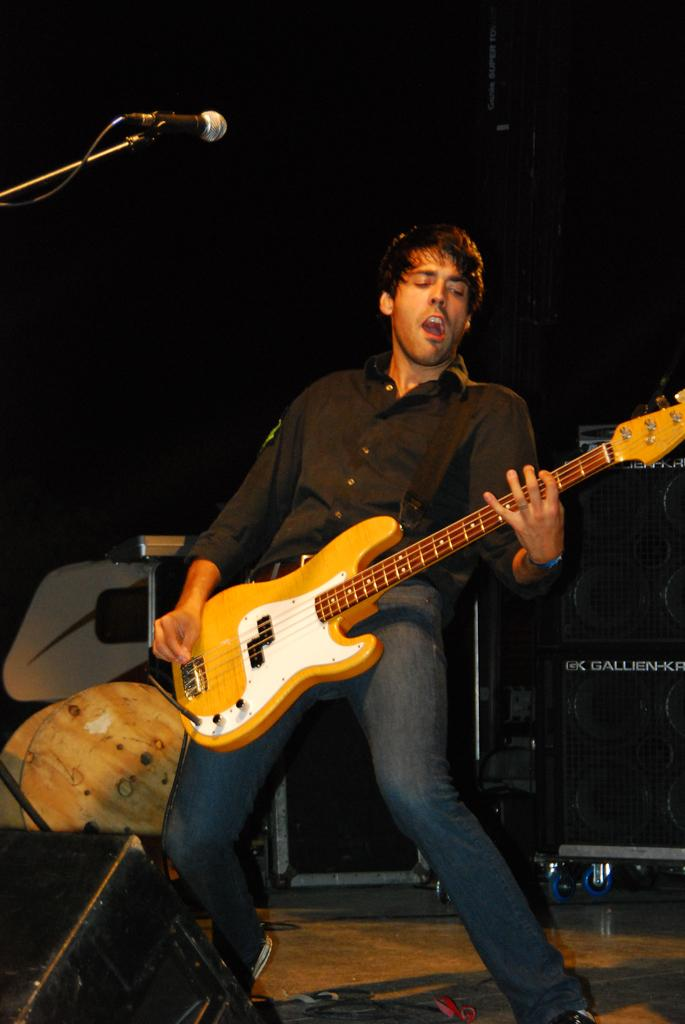What is the person in the image doing? The person is holding a guitar and has a microphone in front of them. What type of clothing is the person wearing? The person is wearing a black shirt. What object is visible in the image that might be used for amplifying sound? There is a speaker visible in the image. What is the weight of the curtain in the image? There is no curtain present in the image, so it is not possible to determine its weight. 